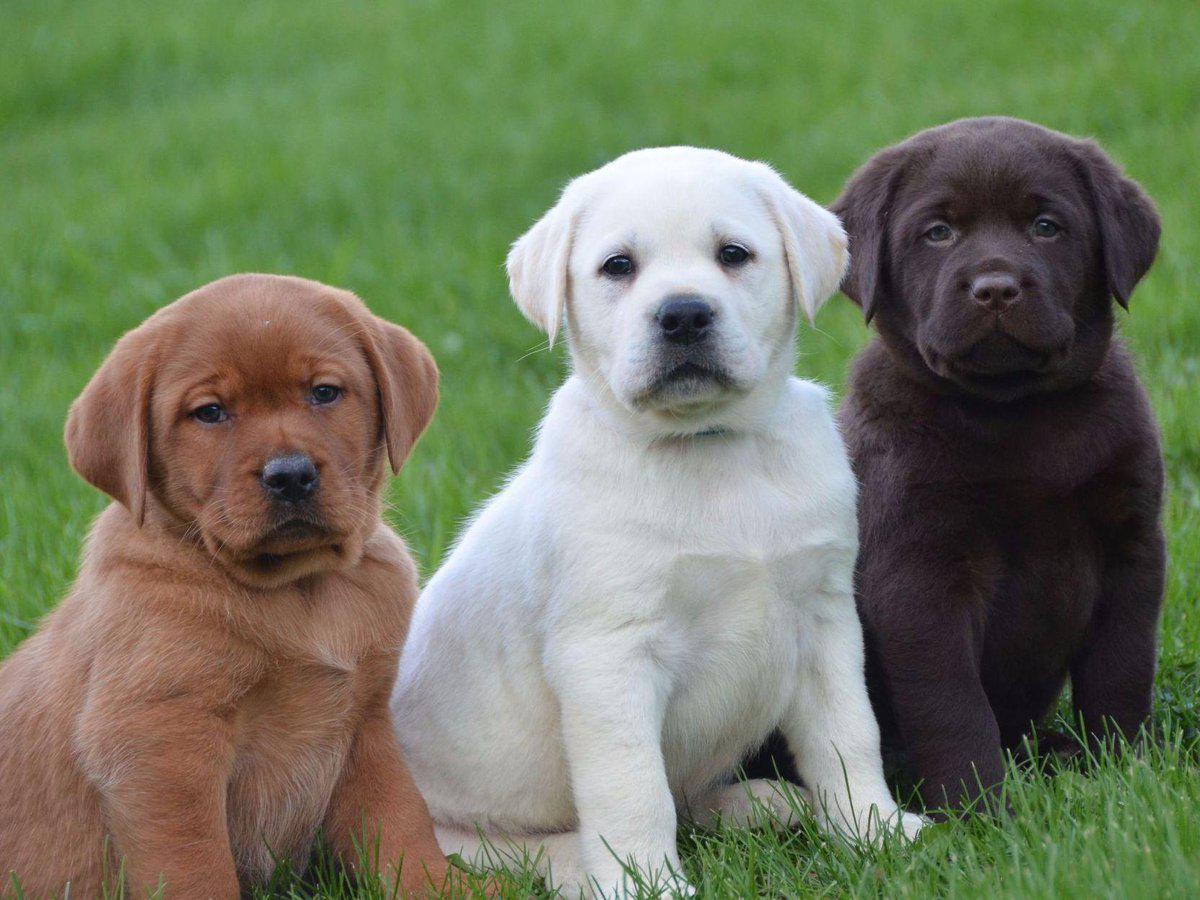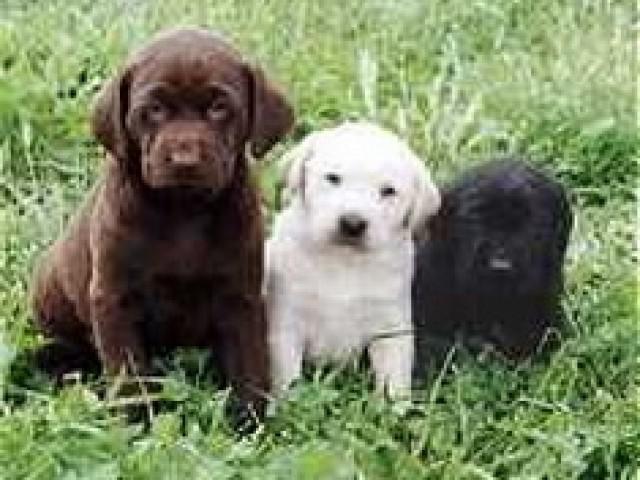The first image is the image on the left, the second image is the image on the right. Assess this claim about the two images: "A pure white puppy is between a dark brown puppy and a black puppy.". Correct or not? Answer yes or no. Yes. 